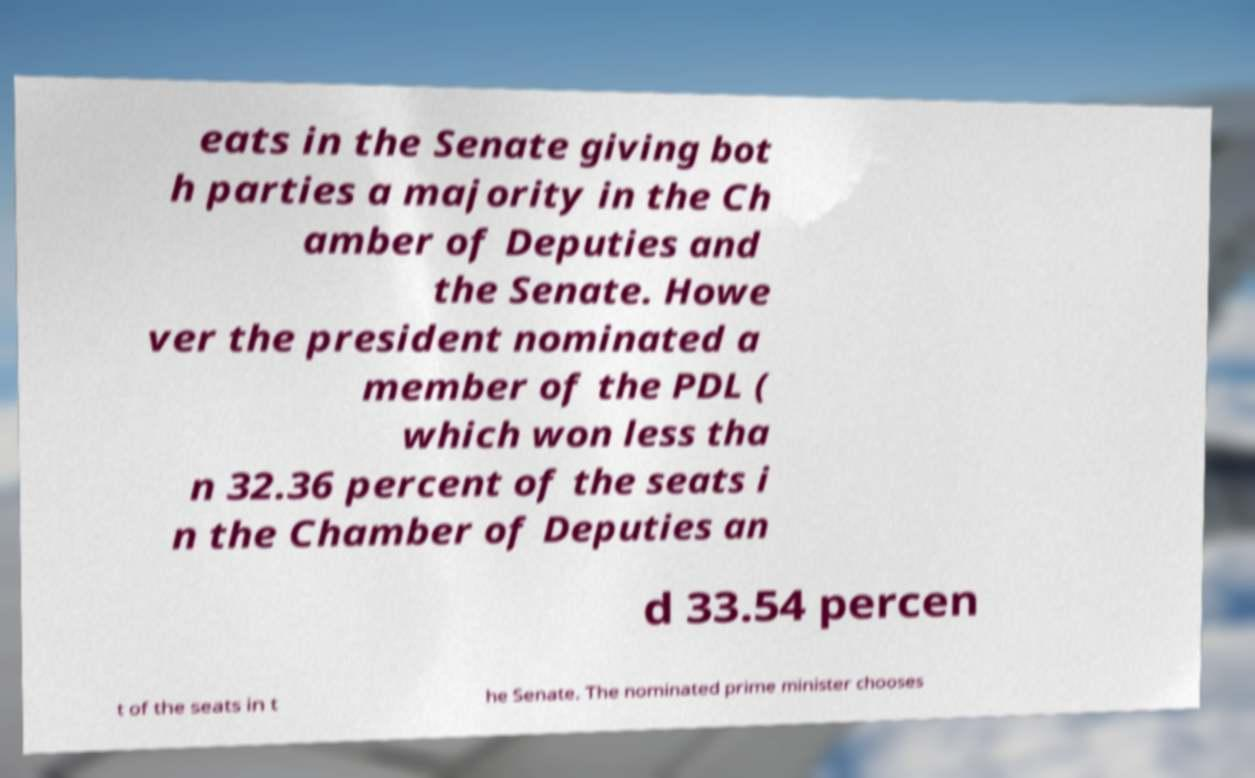Please read and relay the text visible in this image. What does it say? eats in the Senate giving bot h parties a majority in the Ch amber of Deputies and the Senate. Howe ver the president nominated a member of the PDL ( which won less tha n 32.36 percent of the seats i n the Chamber of Deputies an d 33.54 percen t of the seats in t he Senate. The nominated prime minister chooses 